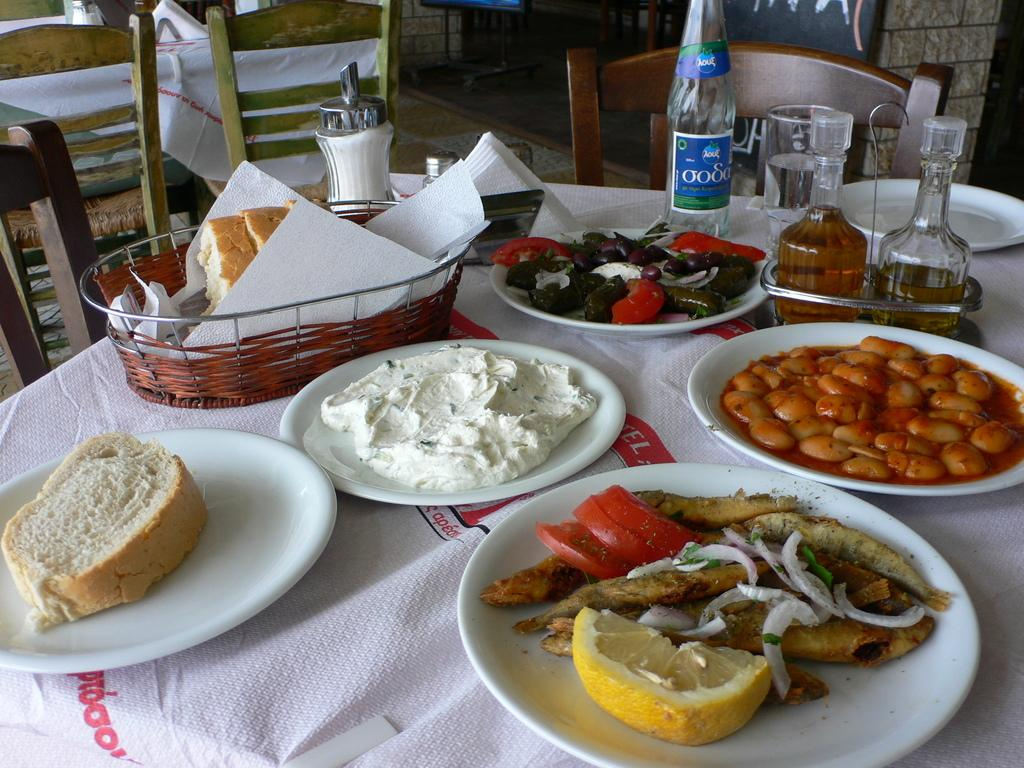What type of furniture is present in the image? There is a chair and a table in the image. What is placed on the table? There is a plate, a bottle, tissue, and food on the table. What can be found on the plate? There is a lemon slice and a tomato slice on the plate. What type of wrench is being used to create steam in the image? There is no wrench or steam present in the image. What arithmetic problem is being solved on the table in the image? There is no arithmetic problem visible in the image. 